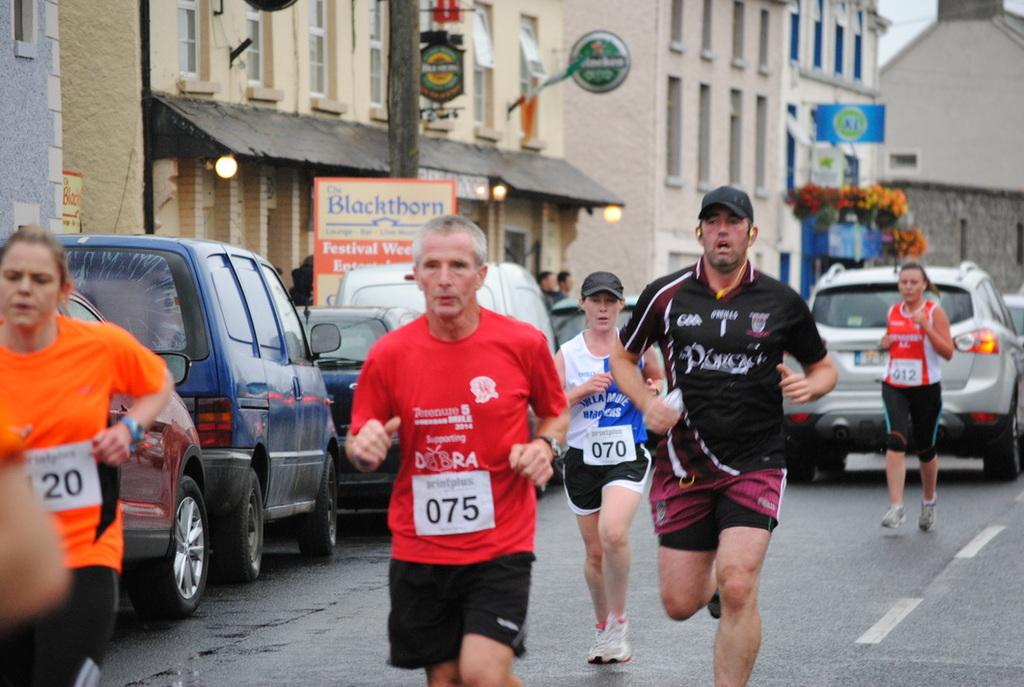Provide a one-sentence caption for the provided image. A runner in a red shirt is runner number 75. 